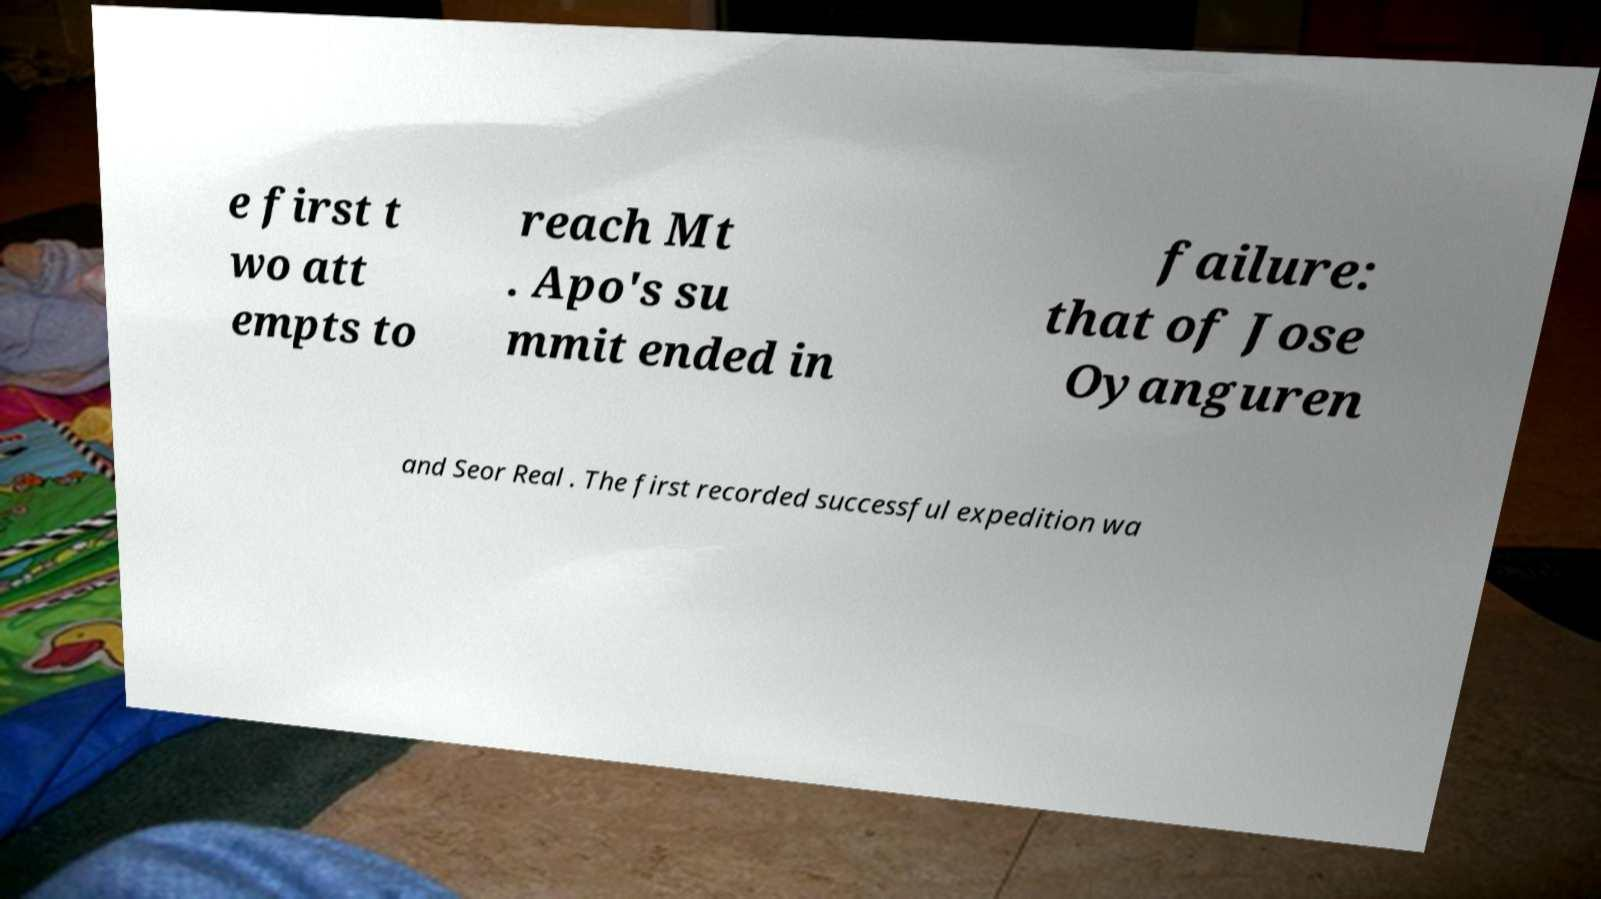There's text embedded in this image that I need extracted. Can you transcribe it verbatim? e first t wo att empts to reach Mt . Apo's su mmit ended in failure: that of Jose Oyanguren and Seor Real . The first recorded successful expedition wa 